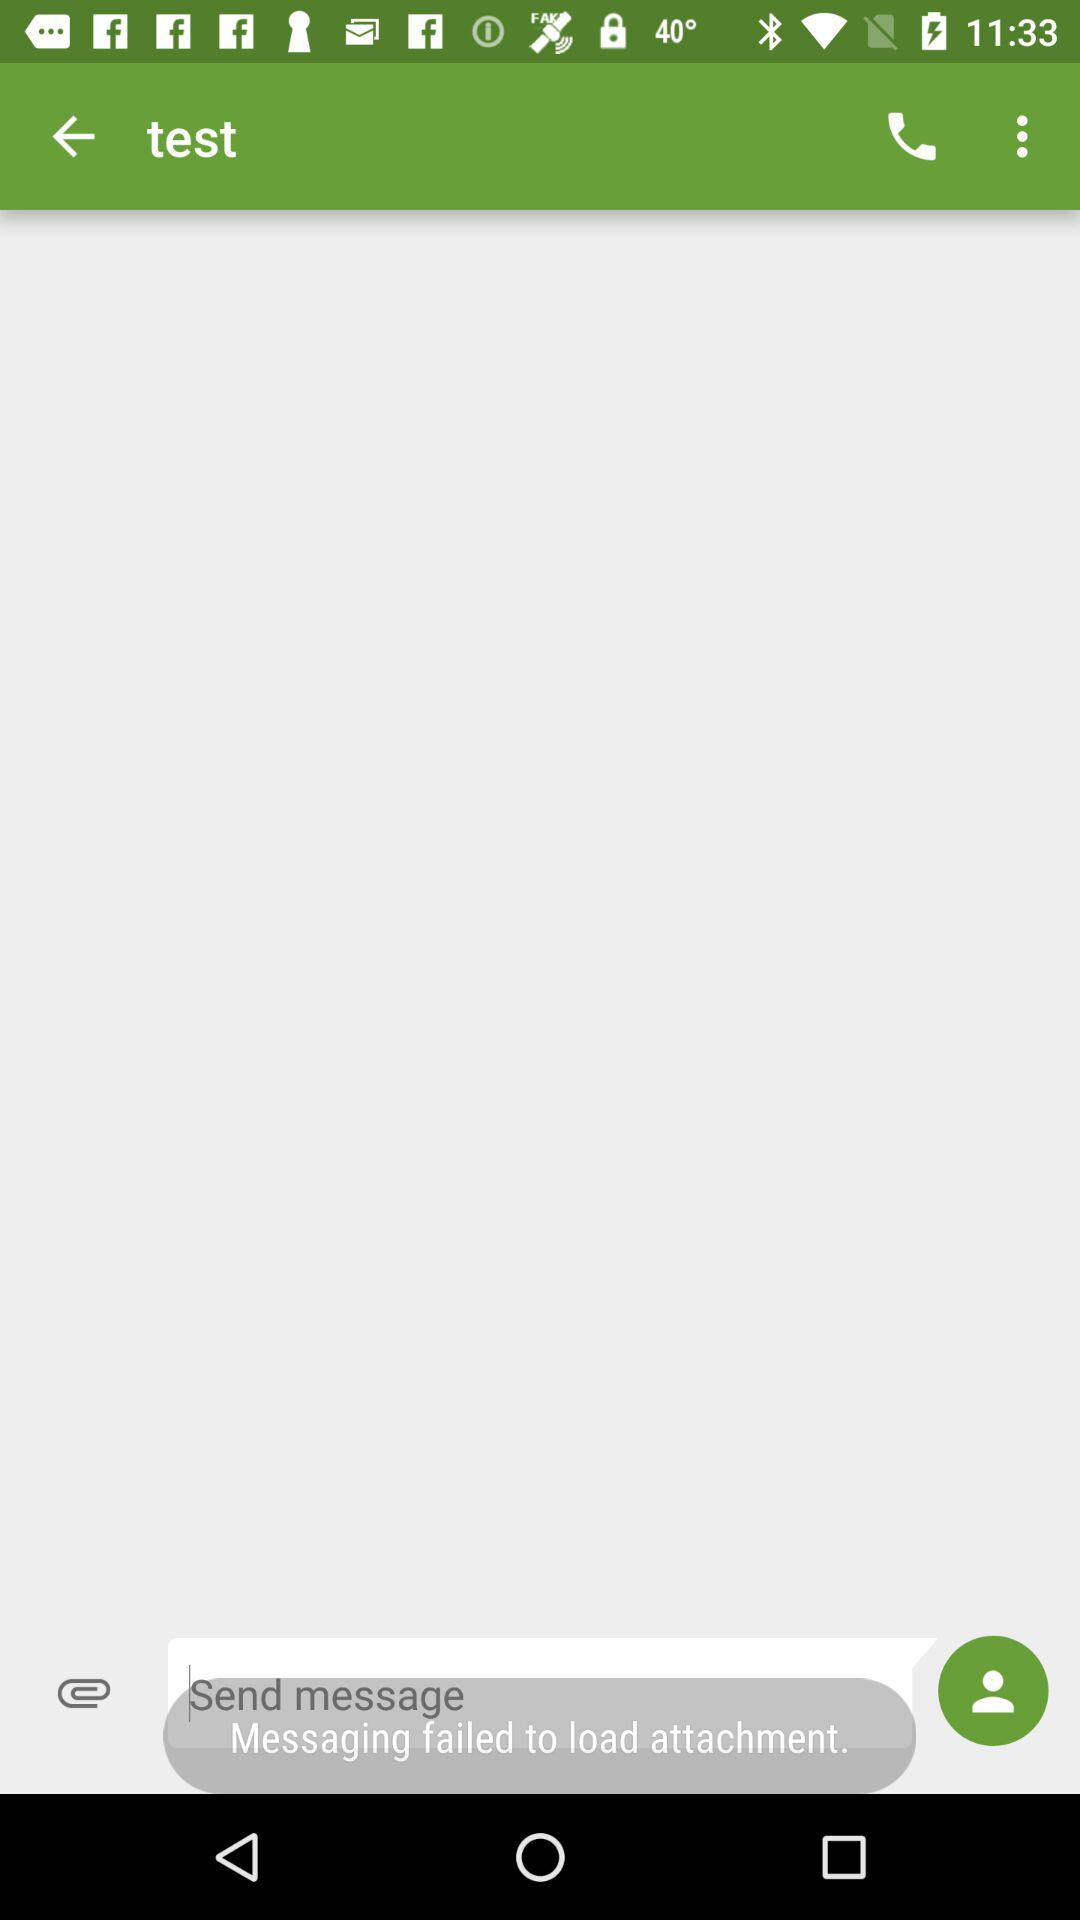Did "Messaging" fail or succeed in loading the attachment? "Messaging" failed to load the attachment. 